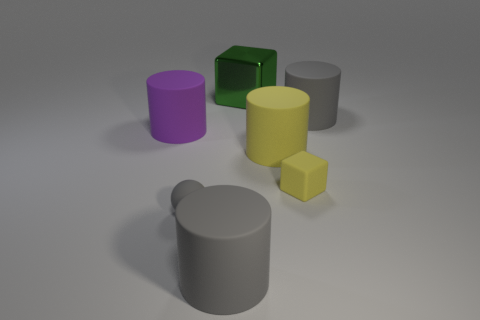There is a large yellow object that is made of the same material as the gray ball; what shape is it?
Your response must be concise. Cylinder. How many other things are the same shape as the tiny yellow object?
Keep it short and to the point. 1. There is a shiny block; what number of purple cylinders are in front of it?
Your response must be concise. 1. There is a gray rubber cylinder that is on the right side of the green thing; does it have the same size as the rubber cylinder in front of the large yellow rubber thing?
Ensure brevity in your answer.  Yes. What number of other things are there of the same size as the green block?
Keep it short and to the point. 4. There is a gray cylinder to the left of the large gray cylinder that is right of the green object left of the tiny yellow rubber block; what is its material?
Provide a short and direct response. Rubber. There is a yellow rubber cylinder; is it the same size as the gray rubber cylinder to the right of the big green metallic block?
Your answer should be very brief. Yes. How big is the object that is both behind the purple matte thing and in front of the big shiny cube?
Give a very brief answer. Large. Is there another tiny matte sphere that has the same color as the tiny sphere?
Provide a succinct answer. No. There is a thing that is behind the large gray cylinder that is behind the small rubber cube; what color is it?
Your answer should be compact. Green. 